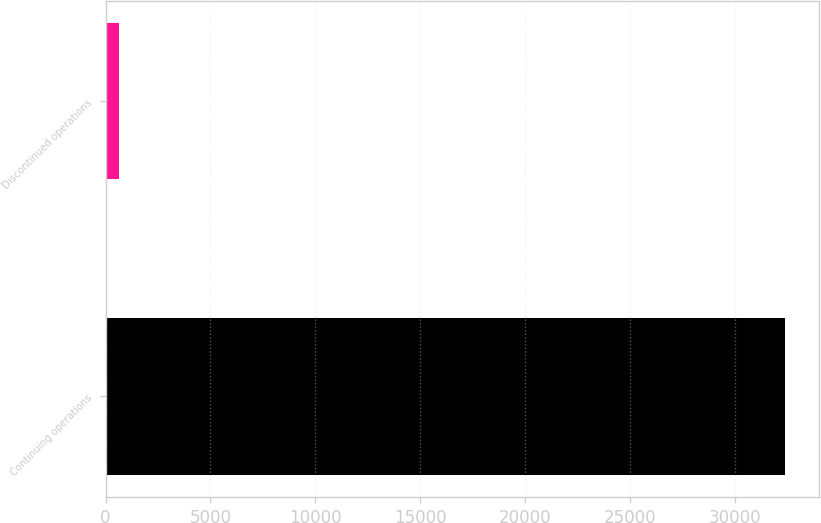Convert chart to OTSL. <chart><loc_0><loc_0><loc_500><loc_500><bar_chart><fcel>Continuing operations<fcel>Discontinued operations<nl><fcel>32412<fcel>665<nl></chart> 